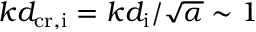<formula> <loc_0><loc_0><loc_500><loc_500>k d _ { c r , i } = k d _ { i } / \sqrt { \alpha } \sim 1</formula> 